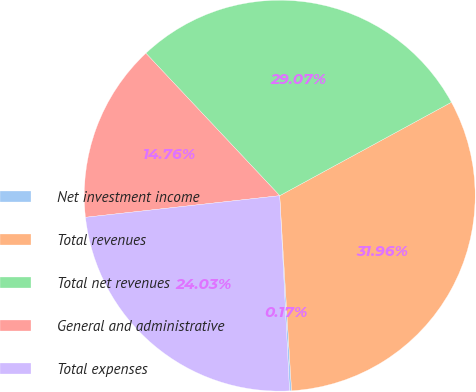Convert chart to OTSL. <chart><loc_0><loc_0><loc_500><loc_500><pie_chart><fcel>Net investment income<fcel>Total revenues<fcel>Total net revenues<fcel>General and administrative<fcel>Total expenses<nl><fcel>0.17%<fcel>31.96%<fcel>29.07%<fcel>14.76%<fcel>24.03%<nl></chart> 